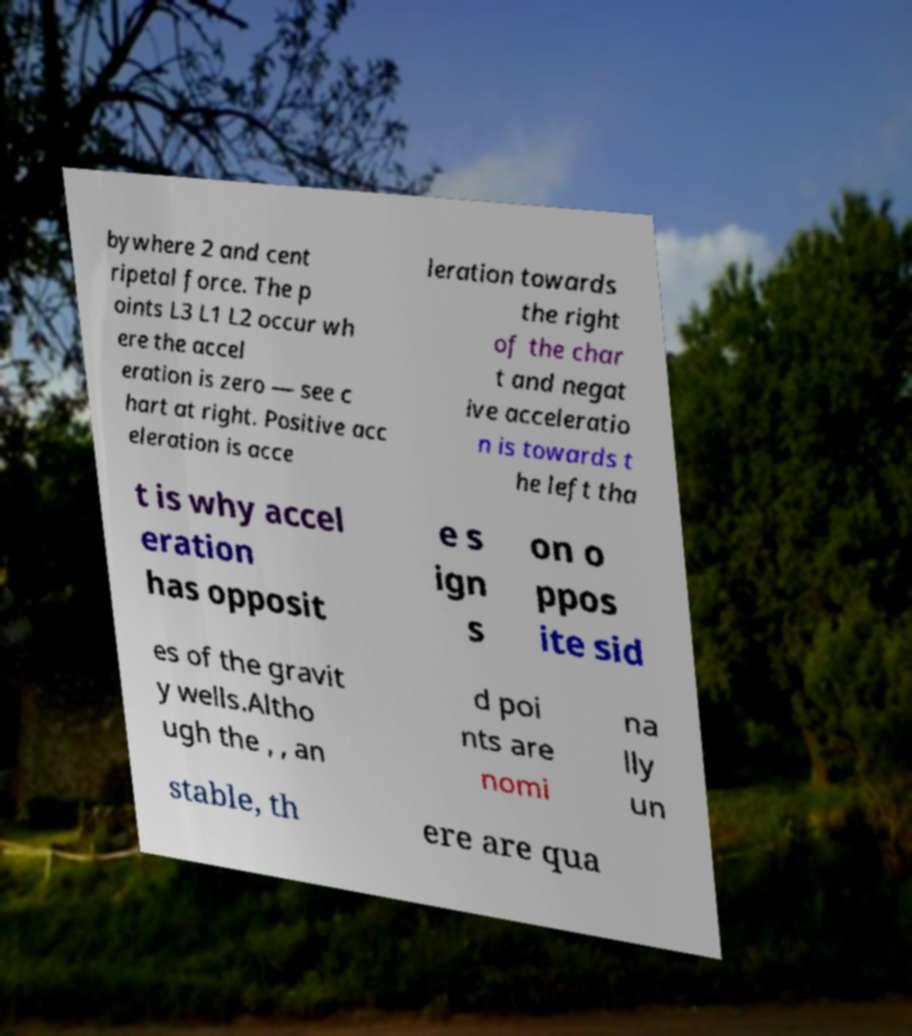There's text embedded in this image that I need extracted. Can you transcribe it verbatim? bywhere 2 and cent ripetal force. The p oints L3 L1 L2 occur wh ere the accel eration is zero — see c hart at right. Positive acc eleration is acce leration towards the right of the char t and negat ive acceleratio n is towards t he left tha t is why accel eration has opposit e s ign s on o ppos ite sid es of the gravit y wells.Altho ugh the , , an d poi nts are nomi na lly un stable, th ere are qua 